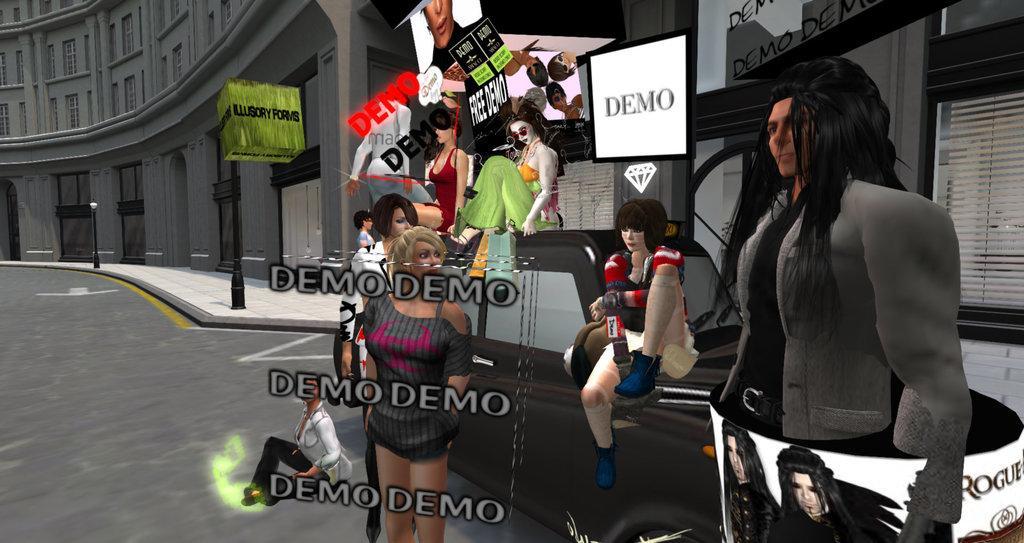In one or two sentences, can you explain what this image depicts? This is an animation picture. In this image there are three people standing and there are three people sitting on the vehicle and there is a person sitting on the road. At the back there is a building and there are boards on the building and there are is text and there are pictures of people on the boards and there are street lights on the footpath. At the bottom there is a road. On the right side of the image there is text on the mirror and there is a window blind. 